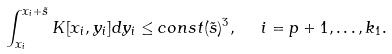Convert formula to latex. <formula><loc_0><loc_0><loc_500><loc_500>\int _ { x _ { i } } ^ { x _ { i } + \tilde { s } } K [ x _ { i } , y _ { i } ] d y _ { i } \leq c o n s t ( \tilde { s } ) ^ { 3 } , \ \ i = p + 1 , \dots , k _ { 1 } .</formula> 